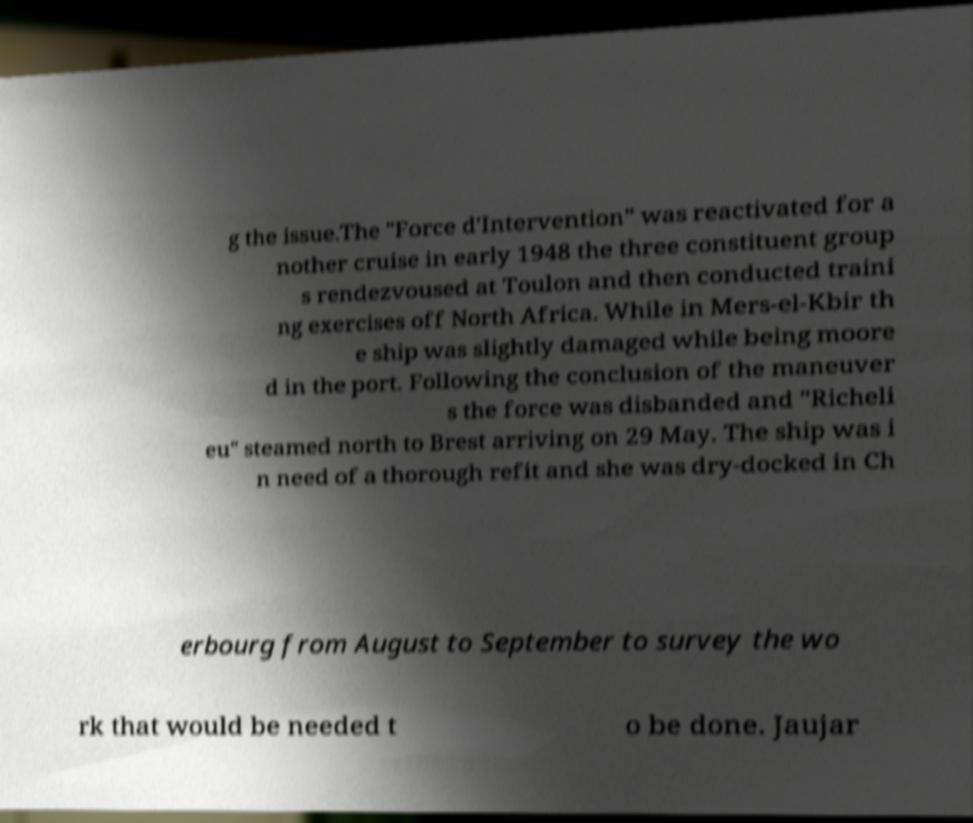Can you read and provide the text displayed in the image?This photo seems to have some interesting text. Can you extract and type it out for me? g the issue.The "Force d'Intervention" was reactivated for a nother cruise in early 1948 the three constituent group s rendezvoused at Toulon and then conducted traini ng exercises off North Africa. While in Mers-el-Kbir th e ship was slightly damaged while being moore d in the port. Following the conclusion of the maneuver s the force was disbanded and "Richeli eu" steamed north to Brest arriving on 29 May. The ship was i n need of a thorough refit and she was dry-docked in Ch erbourg from August to September to survey the wo rk that would be needed t o be done. Jaujar 